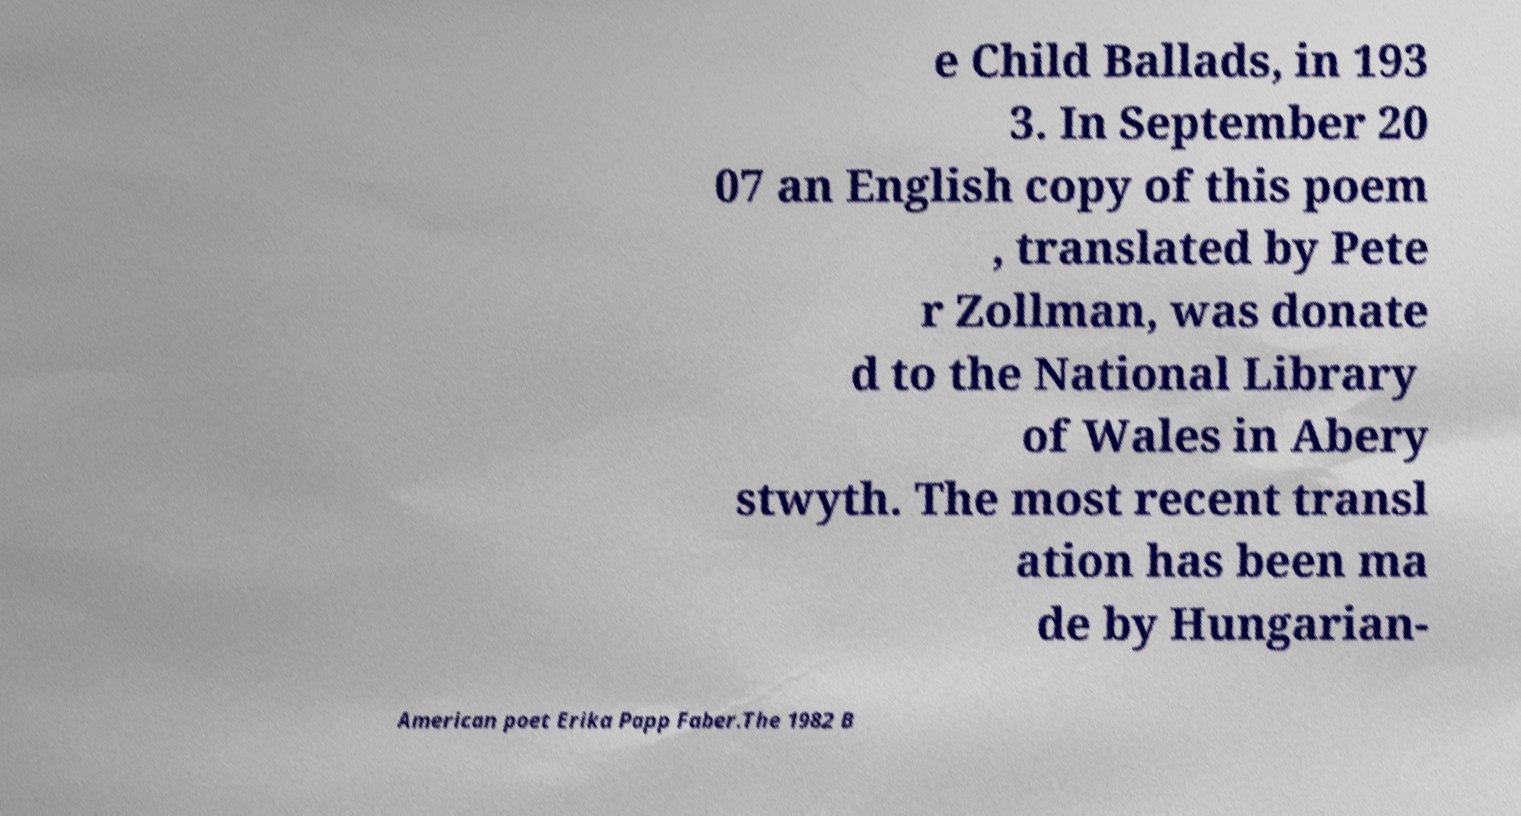Could you assist in decoding the text presented in this image and type it out clearly? e Child Ballads, in 193 3. In September 20 07 an English copy of this poem , translated by Pete r Zollman, was donate d to the National Library of Wales in Abery stwyth. The most recent transl ation has been ma de by Hungarian- American poet Erika Papp Faber.The 1982 B 